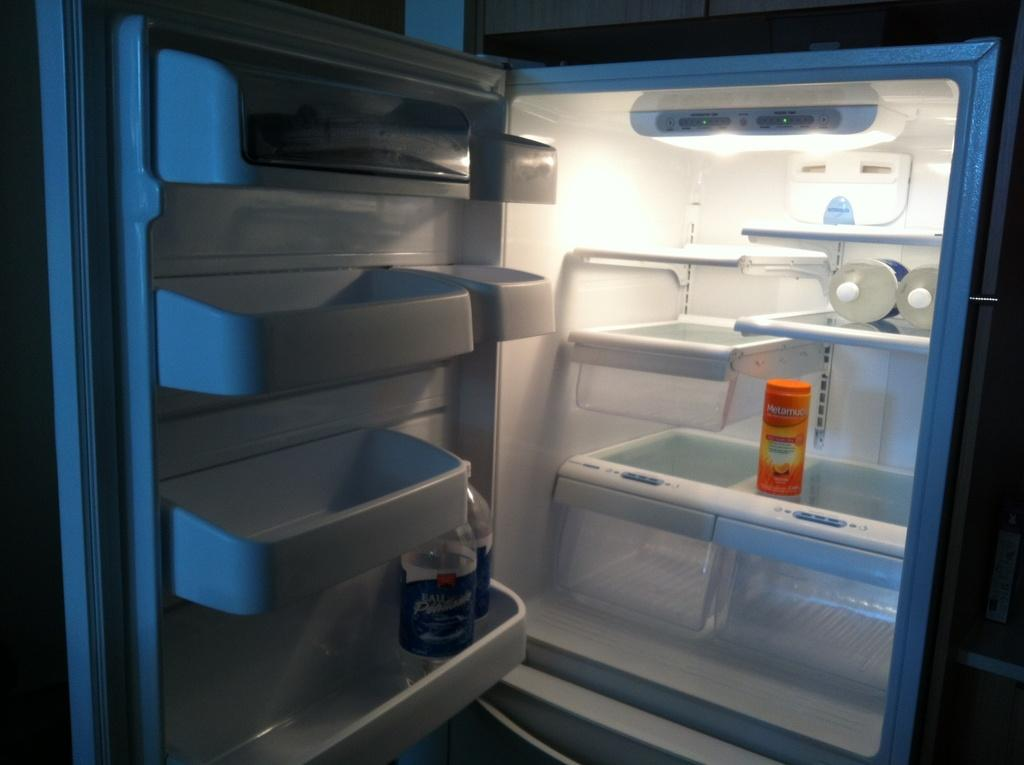<image>
Relay a brief, clear account of the picture shown. the word metamucil is on the orange item in the fridge 